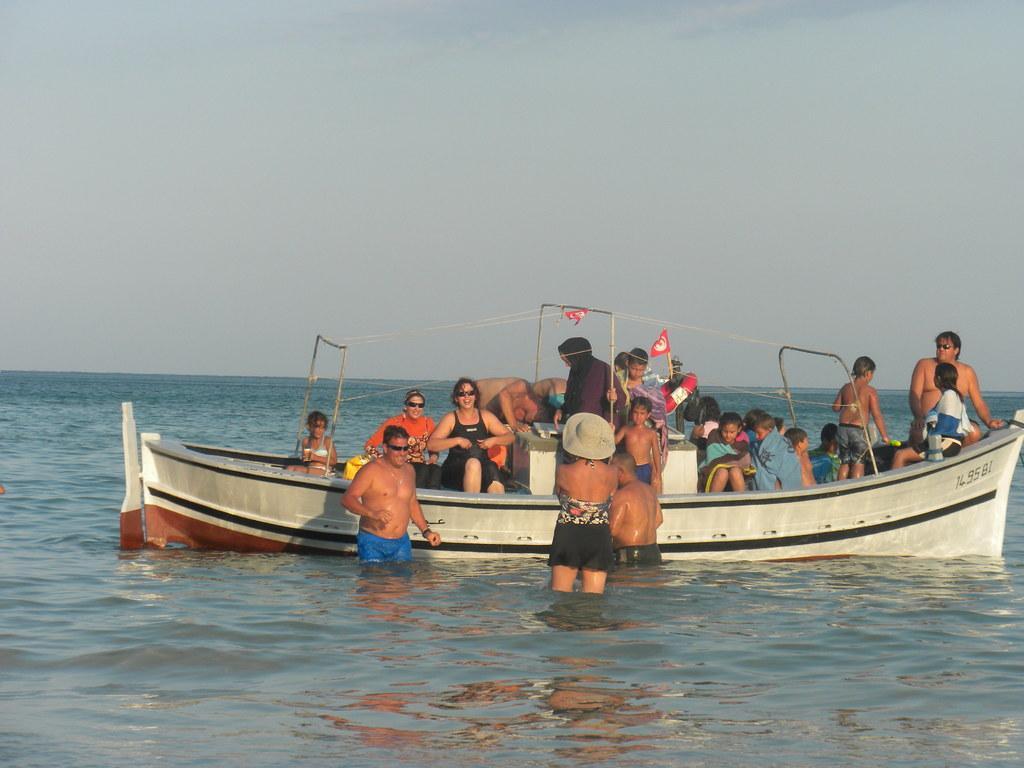Can you describe this image briefly? In the center of the image we can see one boat on the water. In the boat, we can see a few people are sitting and few people are standing. And we can see the wires, flags, one life savior and a few other objects. And we can see three persons are standing in the water. Among them, we can see one person is wearing a hat. In the background we can see the sky, clouds, water etc. 